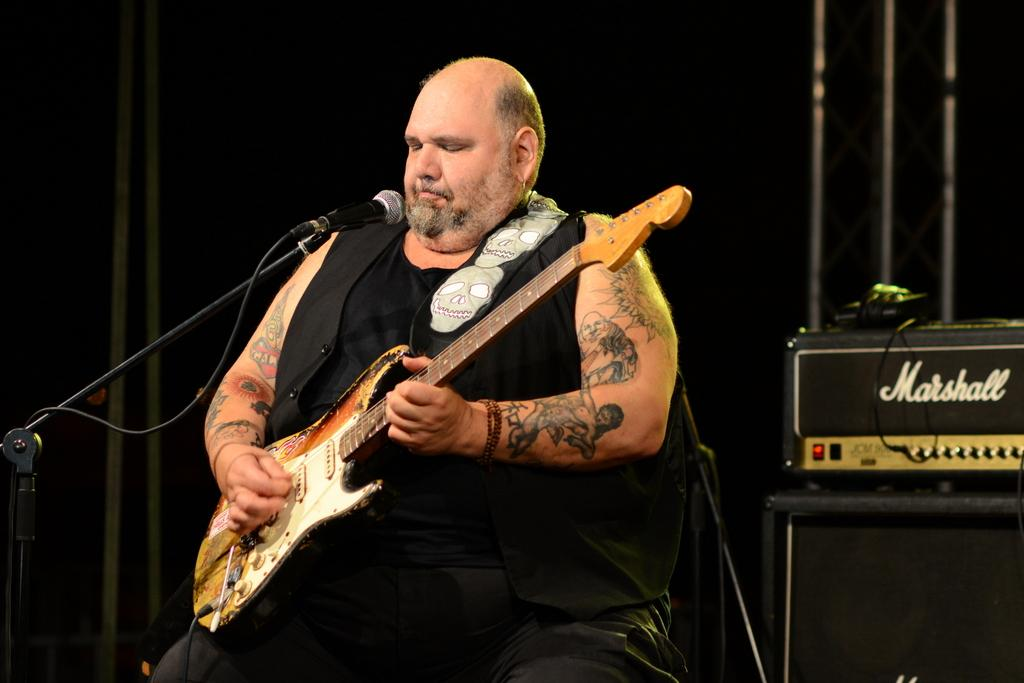What is the man in the image doing? The man is seated on a chair and playing a guitar. What object is in front of the man? There is a microphone in front of the man. What can be seen in the background of the image? There are musical instruments in the background of the image. Can you describe the man's position in the image? The man is seated on a chair. What type of flesh can be seen cooking on the stove in the image? There is no stove or flesh present in the image; it features a man playing a guitar with a microphone and musical instruments in the background. 